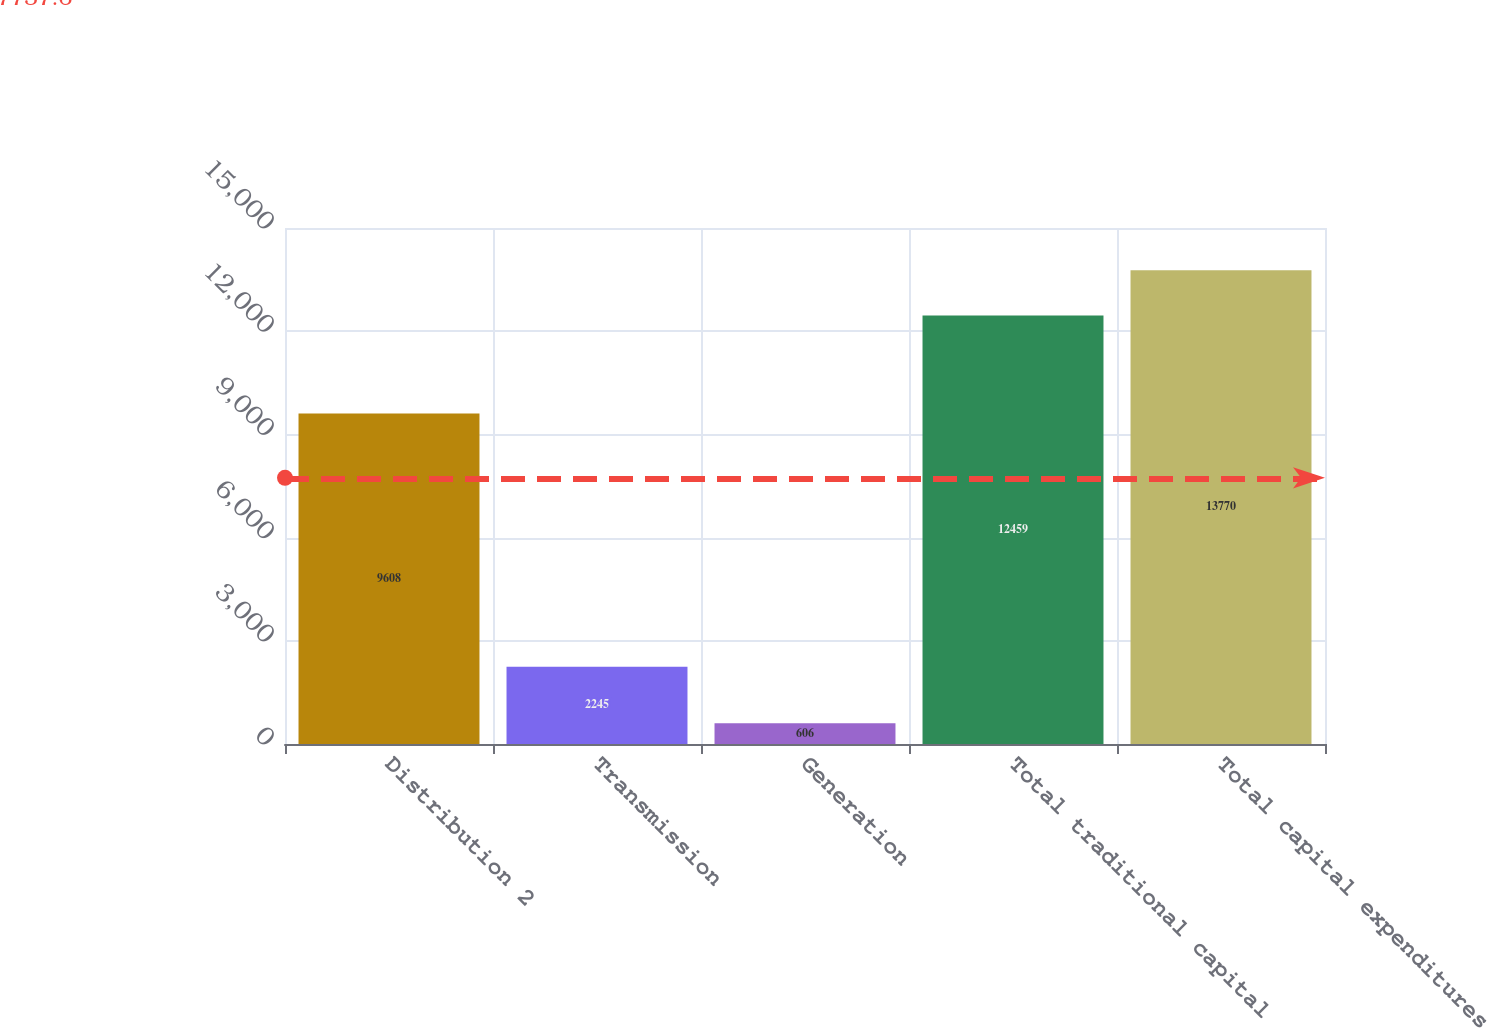Convert chart. <chart><loc_0><loc_0><loc_500><loc_500><bar_chart><fcel>Distribution 2<fcel>Transmission<fcel>Generation<fcel>Total traditional capital<fcel>Total capital expenditures<nl><fcel>9608<fcel>2245<fcel>606<fcel>12459<fcel>13770<nl></chart> 